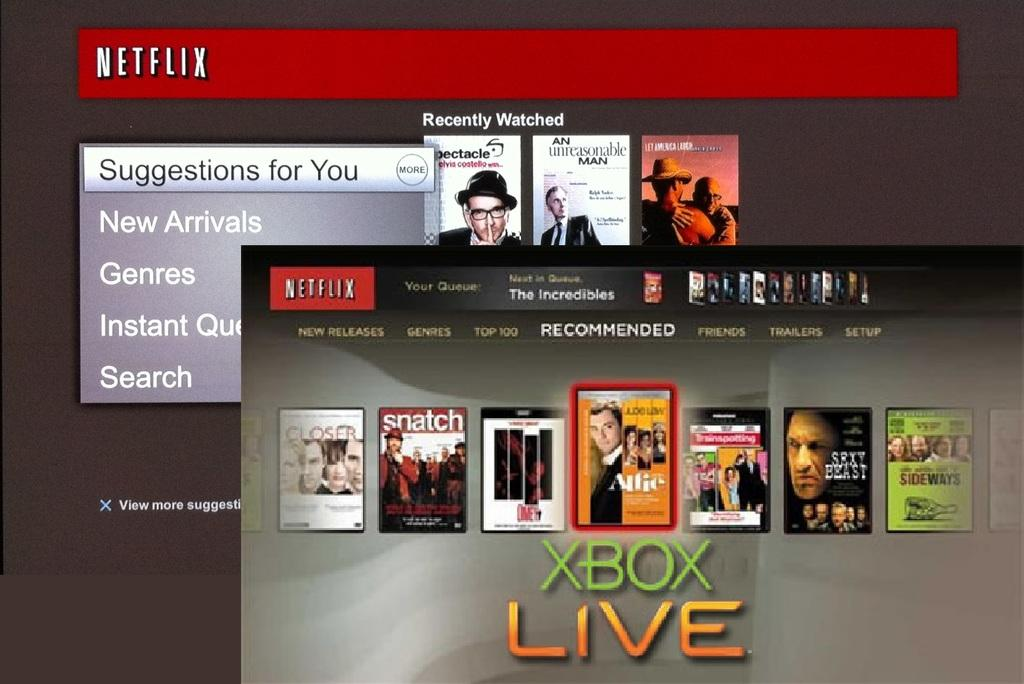<image>
Create a compact narrative representing the image presented. A screen shows a netflix account and an Xbox live account. 